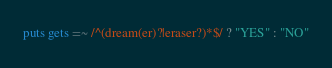<code> <loc_0><loc_0><loc_500><loc_500><_Ruby_>puts gets =~ /^(dream(er)?|eraser?)*$/ ? "YES" : "NO"</code> 